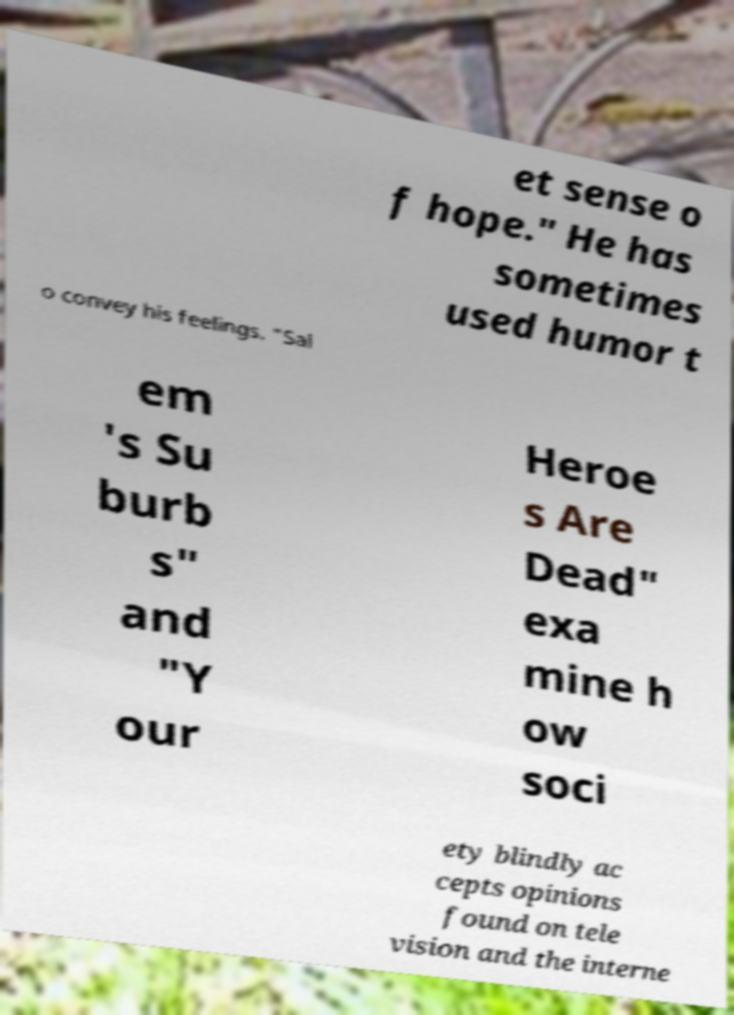What messages or text are displayed in this image? I need them in a readable, typed format. et sense o f hope." He has sometimes used humor t o convey his feelings. "Sal em 's Su burb s" and "Y our Heroe s Are Dead" exa mine h ow soci ety blindly ac cepts opinions found on tele vision and the interne 